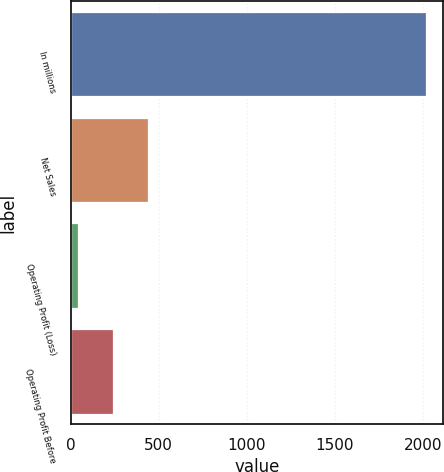<chart> <loc_0><loc_0><loc_500><loc_500><bar_chart><fcel>In millions<fcel>Net Sales<fcel>Operating Profit (Loss)<fcel>Operating Profit Before<nl><fcel>2016<fcel>437.6<fcel>43<fcel>240.3<nl></chart> 